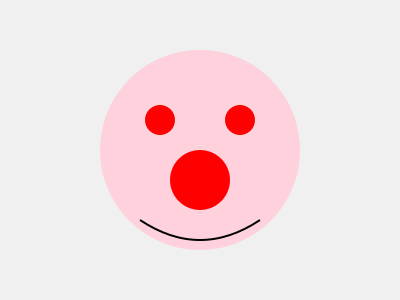Based on the medical illustration provided, what rare skin condition does this patient likely have? To identify this rare skin condition, let's analyze the illustration step-by-step:

1. Overall appearance: The image shows a circular area with a light pink background, suggesting inflamed skin.

2. Distinctive features:
   a. Three prominent red circular lesions are visible.
   b. Two smaller lesions are positioned symmetrically in the upper part.
   c. One larger lesion is centered in the lower part.

3. Pattern recognition: The arrangement of these lesions forms a distinctive "triangle" pattern.

4. Additional symptom: A curved line at the bottom suggests swelling or edema.

5. Connecting the dots: This unique presentation of red, circular lesions in a triangular pattern on inflamed skin, accompanied by facial swelling, is characteristic of a rare condition called Sweet's syndrome.

Sweet's syndrome, also known as acute febrile neutrophilic dermatosis, is a rare inflammatory skin condition. It typically presents with tender, red, well-demarcated papules and plaques, often on the upper body, face, or neck. The triangular arrangement of lesions is a hallmark sign of this condition.

Given the specific presentation in the illustration and the rarity of the condition, Sweet's syndrome is the most likely diagnosis for this skin manifestation.
Answer: Sweet's syndrome 